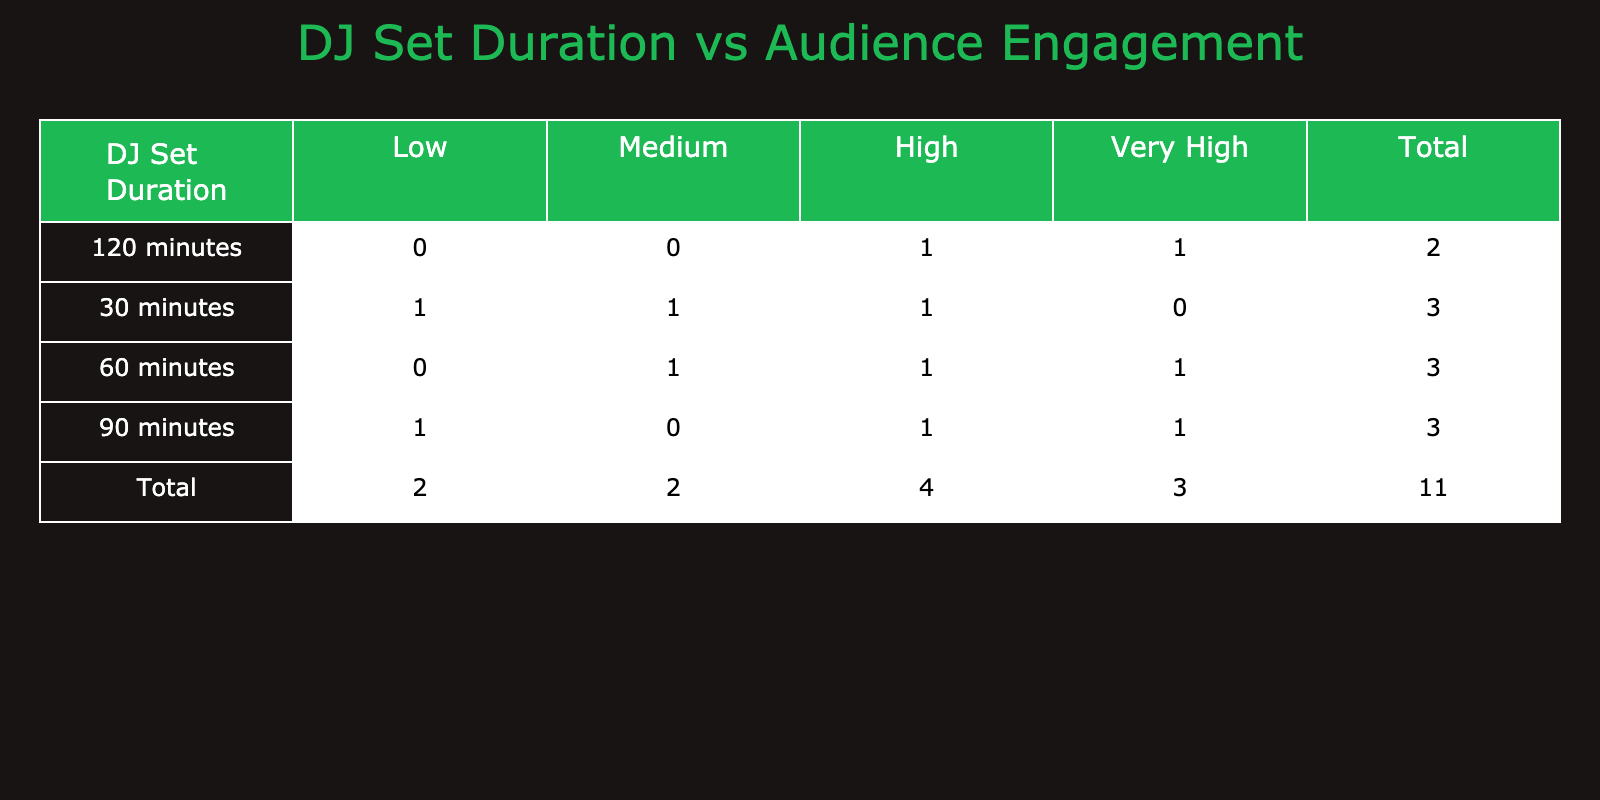What is the highest audience engagement level for a 90-minute DJ set? In the table, under the 90-minute duration, the audience engagement levels listed are High, Very High, and Low. The highest level among these is Very High.
Answer: Very High How many total audience engagements are reported for a 60-minute DJ set? In the table, the engagements reported for the 60-minute duration are Medium (1) and High (1) and Very High (1), which totals to 3 engagements.
Answer: 3 Is there a Low engagement level for a 120-minute DJ set? Looking at the table, under the 120-minute duration there are listings for Very High and High engagement levels only, with no Low level present.
Answer: No What is the total number of engagements at the High audience level? From the table, we see High engagement levels for 30 minutes (1), 60 minutes (1), 90 minutes (1), and 120 minutes (1), totaling 4 High engagements overall.
Answer: 4 Compare the number of Low engagements for 30 and 90-minute sets. Which is greater? For the 30-minute duration, there is 1 Low engagement, while for the 90-minute duration, there is also 1 Low engagement. Thus, they are equal.
Answer: Equal What percentage of the 120-minute DJ sets resulted in Very High engagement? There are 2 engagements listed for the 120-minute duration, with 1 being Very High, which gives (1/2) * 100% = 50%.
Answer: 50% What is the combined number of Medium and High engagements for the 30-minute DJ set? The engagements for the 30-minute DJ set listed are Low (1), Medium (1), and High (1). Summing Medium (1) and High (1) gives a total of 2 engagements.
Answer: 2 For the DJ sets that lasted 60 minutes, what is the range of audience engagement levels? The engagements for the 60-minute sets are Medium, High, and Very High. The lowest engagement is Medium and the highest is Very High, forming a range of Medium to Very High.
Answer: Medium to Very High If we were to average the total number of engagements across all durations, what would it be? The total engagements are 1 (30 Low) + 1 (30 Medium) + 1 (30 High) + 1 (60 Medium) + 1 (60 High) + 1 (60 Very High) + 1 (90 High) + 1 (90 Very High) + 1 (90 Low) + 1 (120 Very High) + 1 (120 High) = 11 total engagements. Dividing by 5 unique durations gives an average of 11/5 = 2.2.
Answer: 2.2 